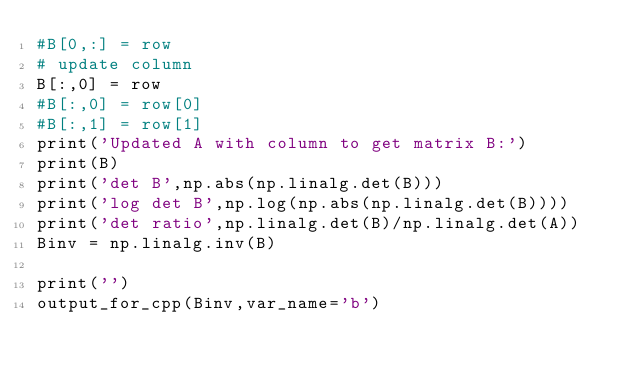Convert code to text. <code><loc_0><loc_0><loc_500><loc_500><_Python_>#B[0,:] = row
# update column
B[:,0] = row
#B[:,0] = row[0]
#B[:,1] = row[1]
print('Updated A with column to get matrix B:')
print(B)
print('det B',np.abs(np.linalg.det(B)))
print('log det B',np.log(np.abs(np.linalg.det(B))))
print('det ratio',np.linalg.det(B)/np.linalg.det(A))
Binv = np.linalg.inv(B)

print('')
output_for_cpp(Binv,var_name='b')
</code> 